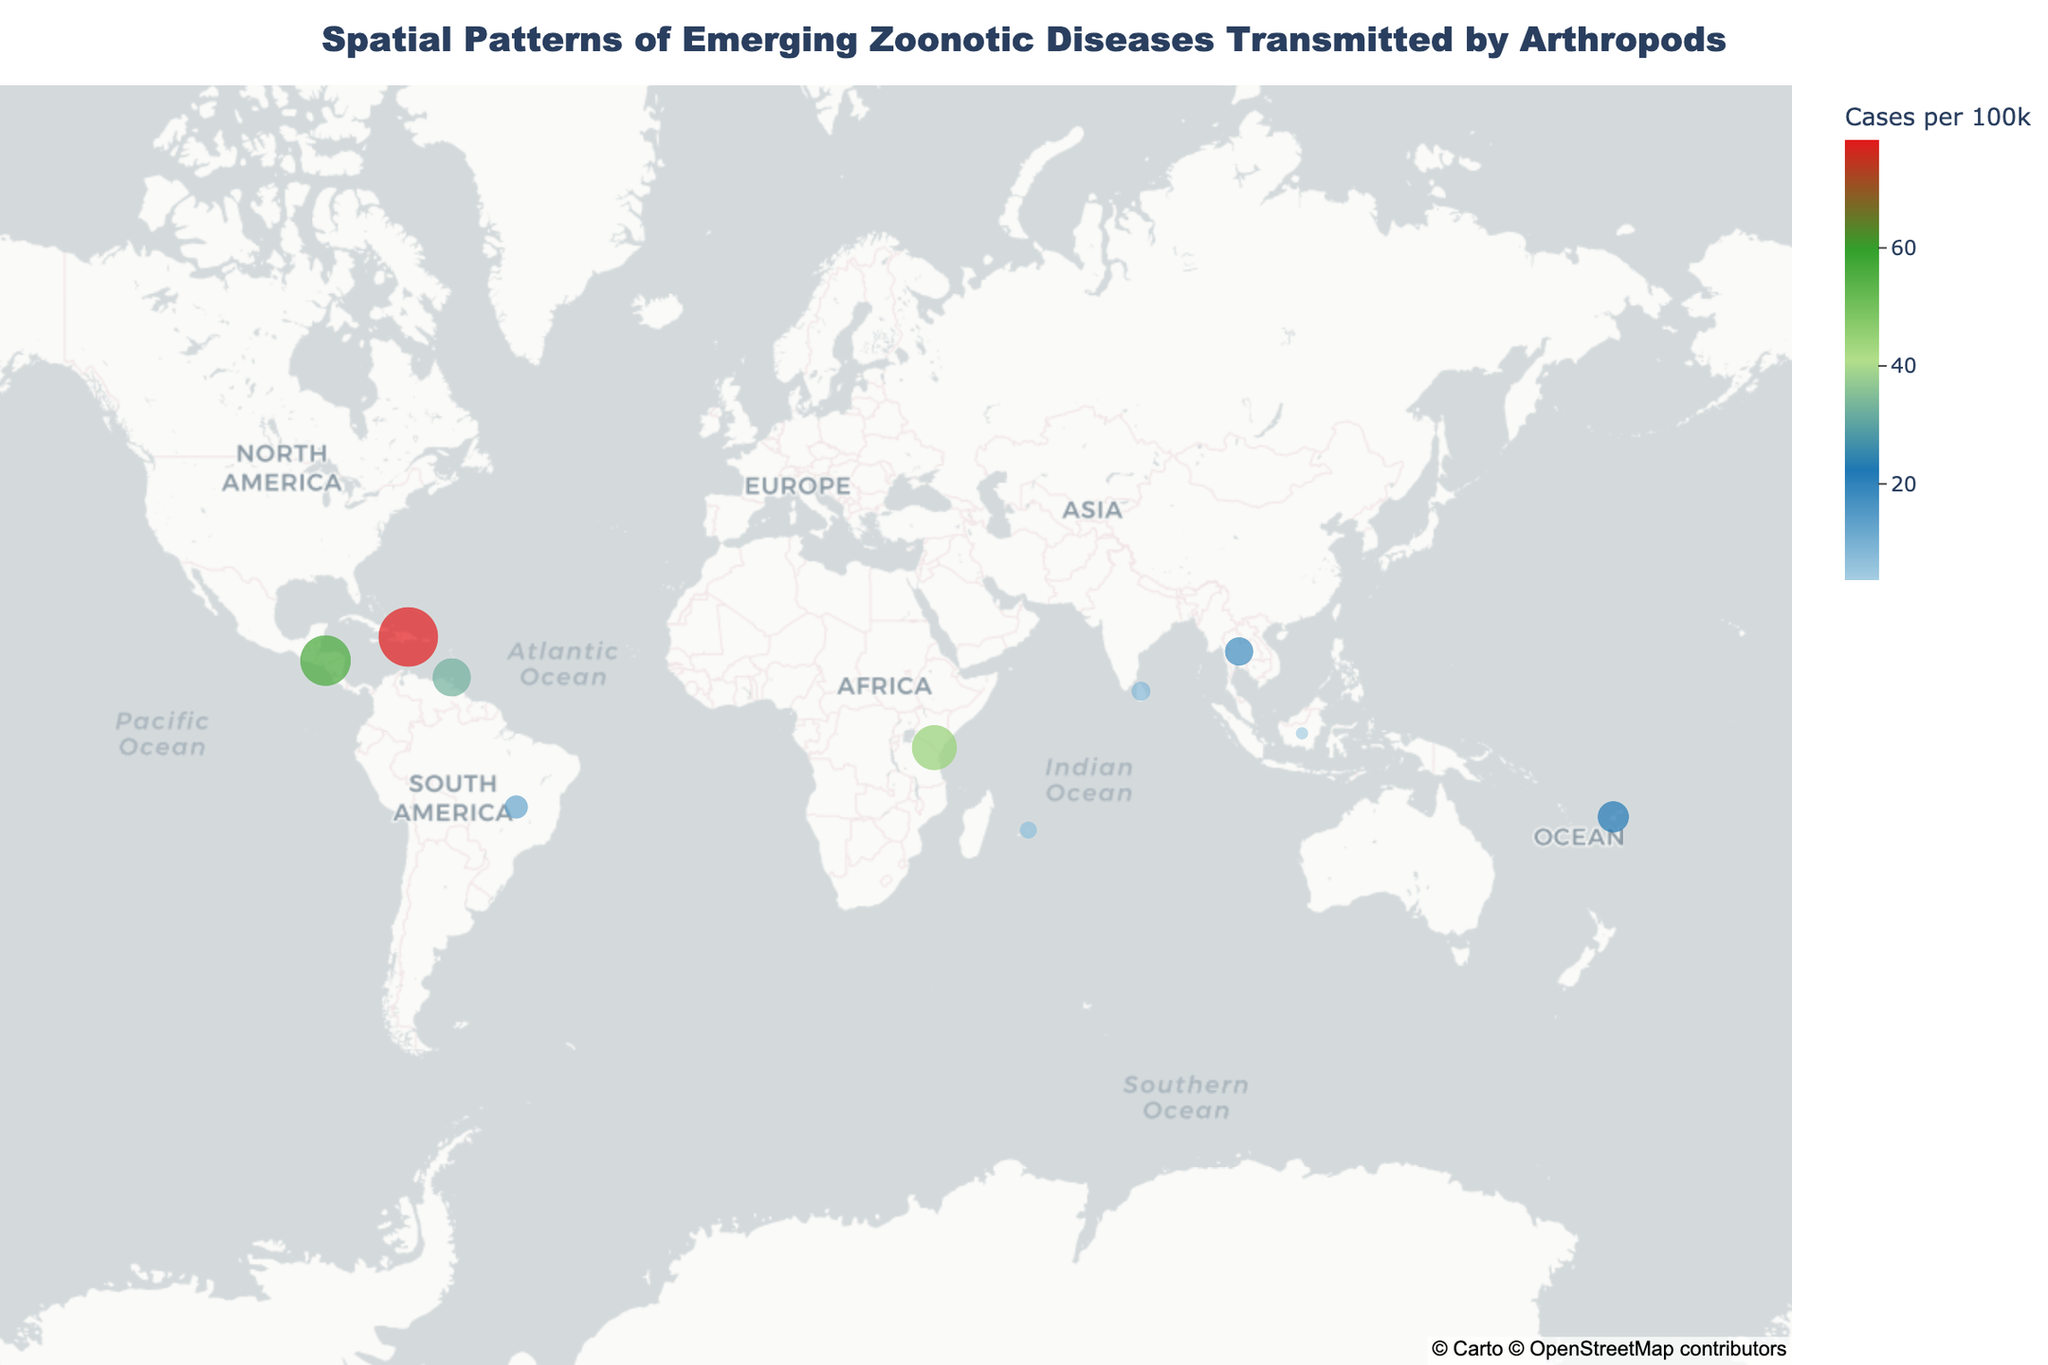What's the title of the plot? The title of the plot is prominently displayed at the top center of the plot.
Answer: Spatial Patterns of Emerging Zoonotic Diseases Transmitted by Arthropods How many different diseases are represented in the plot? The plot has distinct labels for each disease, visible in the data points. Counting these labels, we find there are 10 different diseases represented.
Answer: 10 Which disease has the highest number of cases per 100k? By looking at the size of the markers, the largest marker corresponds to the disease with the highest cases per 100k. The largest marker is labeled "Dengue" with 78.3 cases per 100k in the Dominican Republic.
Answer: Dengue Which region has the most diseases represented? Observing the geographic spread and the labels, we notice that different regions have multiple diseases represented. By matching regions with disease counts, Brazil has both Yellow Fever, among others.
Answer: Brazil What is the average number of cases per 100k across all diseases? To find the average, sum up the cases per 100k for all diseases and divide by the number of diseases. Sum = 45.2 + 32.7 + 78.3 + 12.5 + 56.9 + 8.4 + 3.7 + 22.1 + 6.8 + 18.3 = 284.9. Number of diseases = 10. Average = 284.9 / 10 = 28.49.
Answer: 28.49 In which regions were 'Aedes' mosquito species identified as vectors? The labels indicate the 'Aedes' mosquito species as vectors in Kenya, Trinidad and Tobago, Dominican Republic, Fiji, and Mauritius. Verification is based on the Disease and Arthropod_Vector data for Aedes aegypti, Aedes albopictus, Aedes vigilax, and Aedes mcintoshi.
Answer: Kenya, Trinidad and Tobago, Dominican Republic, Fiji, Mauritius Which disease shows the lowest number of cases per 100k and in which region? Among all the labeled points, the smallest marker corresponds to 'West Nile Virus' in Indonesia, shown with 3.7 cases per 100k.
Answer: West Nile Virus, Indonesia How many tropical and subtropical regions are represented in the data? By examining the regions listed: Kenya, Trinidad and Tobago, Dominican Republic, Brazil, Honduras, Sri Lanka, Indonesia, Fiji, Mauritius, and Thailand, all these regions are categorized as tropical and subtropical.
Answer: 10 Which disease transmitted by 'Culex' mosquitoes has the higher cases per 100k? From the plot, we see two diseases transmitted by Culex species: Japanese Encephalitis (8.4 cases) and West Nile Virus (3.7 cases). Japanese Encephalitis has the higher cases per 100k.
Answer: Japanese Encephalitis 